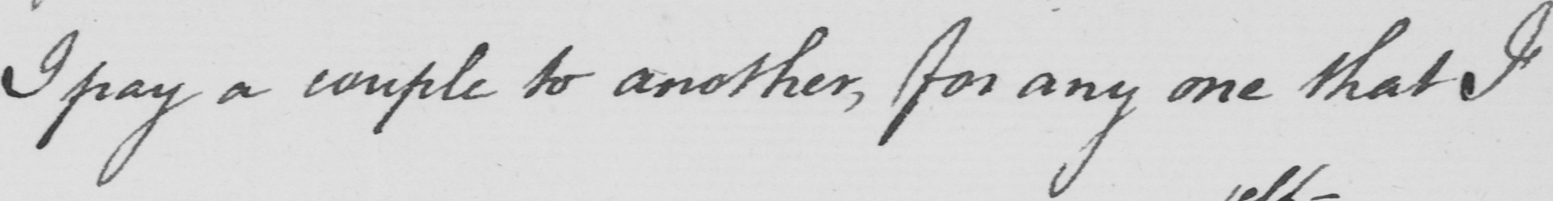Transcribe the text shown in this historical manuscript line. I pay a couple to another, for any one that I 